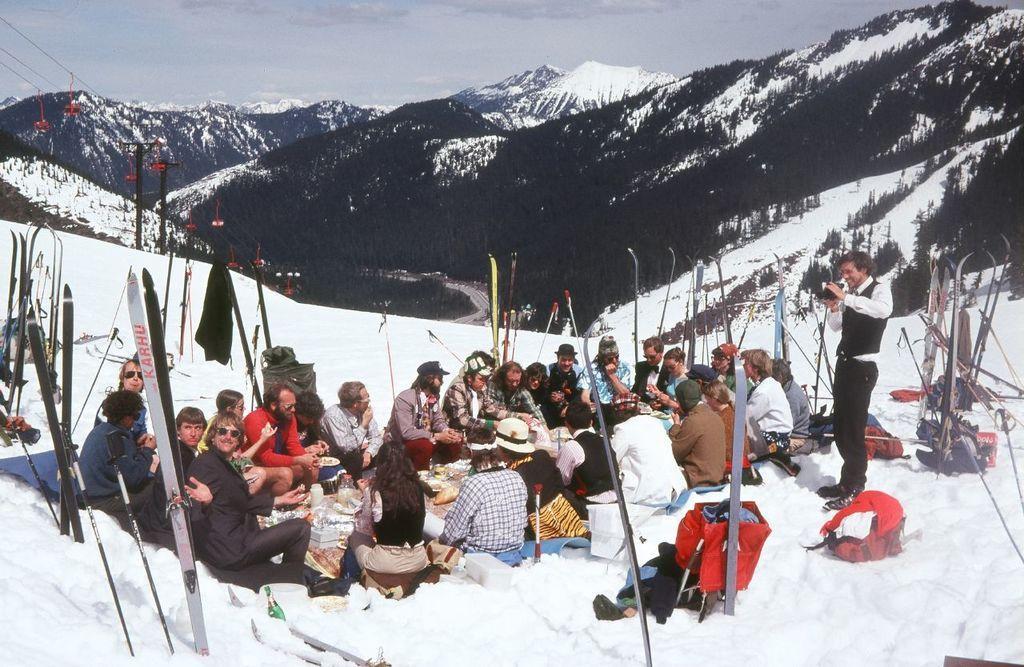In one or two sentences, can you explain what this image depicts? In this image there are a few people sitting and standing on the snow, there are a few food items and luggages are placed on the surface, around them there are few objects like sticks. On the left side of the image there are few cable cars. In the background there are mountains and the sky. 